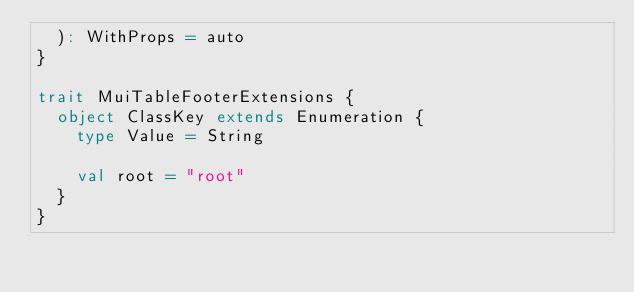Convert code to text. <code><loc_0><loc_0><loc_500><loc_500><_Scala_>  ): WithProps = auto
}

trait MuiTableFooterExtensions {
  object ClassKey extends Enumeration {
    type Value = String

    val root = "root"
  }
}
</code> 